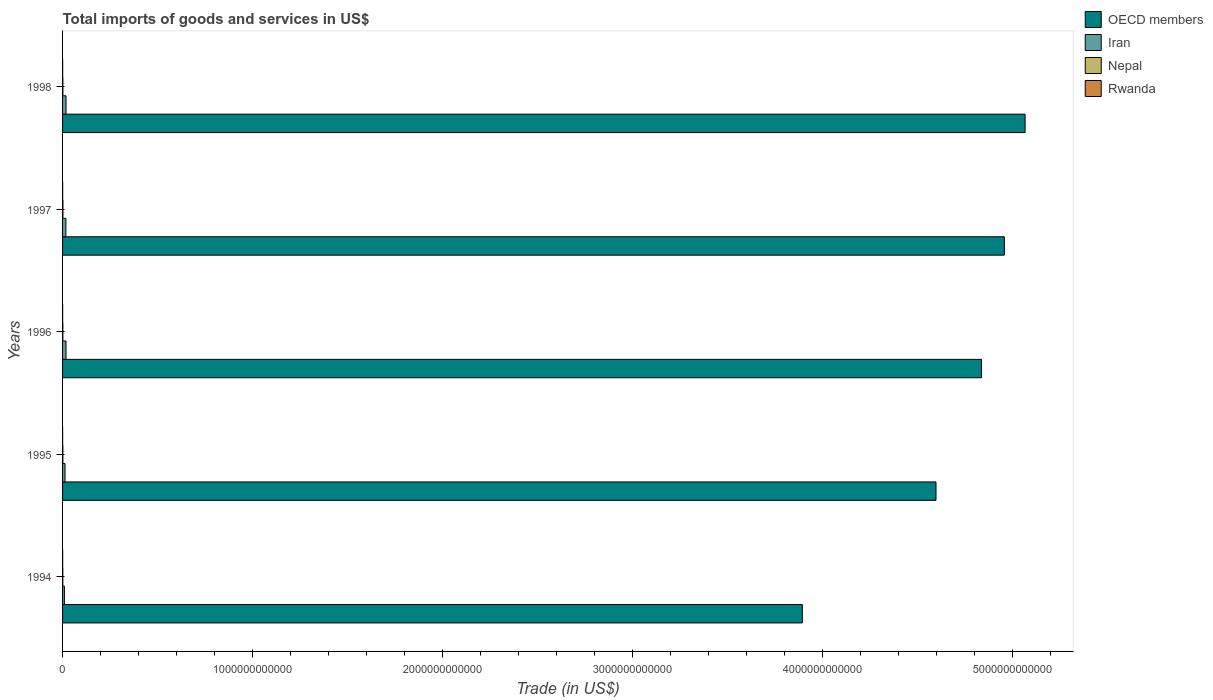How many bars are there on the 4th tick from the top?
Your answer should be very brief. 4. What is the label of the 3rd group of bars from the top?
Offer a terse response. 1996. In how many cases, is the number of bars for a given year not equal to the number of legend labels?
Give a very brief answer. 0. What is the total imports of goods and services in Rwanda in 1994?
Offer a terse response. 4.88e+08. Across all years, what is the maximum total imports of goods and services in Rwanda?
Offer a terse response. 4.88e+08. Across all years, what is the minimum total imports of goods and services in OECD members?
Provide a short and direct response. 3.89e+12. In which year was the total imports of goods and services in Rwanda maximum?
Ensure brevity in your answer.  1994. What is the total total imports of goods and services in Rwanda in the graph?
Ensure brevity in your answer.  2.12e+09. What is the difference between the total imports of goods and services in Nepal in 1994 and that in 1997?
Provide a succinct answer. -5.76e+08. What is the difference between the total imports of goods and services in Iran in 1995 and the total imports of goods and services in OECD members in 1998?
Provide a short and direct response. -5.05e+12. What is the average total imports of goods and services in Iran per year?
Provide a short and direct response. 1.53e+1. In the year 1996, what is the difference between the total imports of goods and services in OECD members and total imports of goods and services in Nepal?
Make the answer very short. 4.84e+12. In how many years, is the total imports of goods and services in Rwanda greater than 3800000000000 US$?
Your response must be concise. 0. What is the ratio of the total imports of goods and services in Iran in 1994 to that in 1996?
Provide a succinct answer. 0.53. Is the difference between the total imports of goods and services in OECD members in 1997 and 1998 greater than the difference between the total imports of goods and services in Nepal in 1997 and 1998?
Provide a succinct answer. No. What is the difference between the highest and the second highest total imports of goods and services in Rwanda?
Your answer should be very brief. 1.30e+07. What is the difference between the highest and the lowest total imports of goods and services in Nepal?
Ensure brevity in your answer.  5.76e+08. In how many years, is the total imports of goods and services in OECD members greater than the average total imports of goods and services in OECD members taken over all years?
Your answer should be compact. 3. What does the 2nd bar from the top in 1997 represents?
Offer a very short reply. Nepal. How many bars are there?
Your response must be concise. 20. What is the difference between two consecutive major ticks on the X-axis?
Provide a succinct answer. 1.00e+12. Where does the legend appear in the graph?
Offer a terse response. Top right. What is the title of the graph?
Make the answer very short. Total imports of goods and services in US$. What is the label or title of the X-axis?
Ensure brevity in your answer.  Trade (in US$). What is the label or title of the Y-axis?
Keep it short and to the point. Years. What is the Trade (in US$) of OECD members in 1994?
Give a very brief answer. 3.89e+12. What is the Trade (in US$) of Iran in 1994?
Your answer should be compact. 9.57e+09. What is the Trade (in US$) in Nepal in 1994?
Make the answer very short. 1.28e+09. What is the Trade (in US$) in Rwanda in 1994?
Offer a terse response. 4.88e+08. What is the Trade (in US$) in OECD members in 1995?
Offer a very short reply. 4.60e+12. What is the Trade (in US$) of Iran in 1995?
Offer a terse response. 1.30e+1. What is the Trade (in US$) of Nepal in 1995?
Ensure brevity in your answer.  1.52e+09. What is the Trade (in US$) in Rwanda in 1995?
Your answer should be very brief. 3.34e+08. What is the Trade (in US$) in OECD members in 1996?
Your answer should be very brief. 4.84e+12. What is the Trade (in US$) in Iran in 1996?
Ensure brevity in your answer.  1.81e+1. What is the Trade (in US$) in Nepal in 1996?
Offer a terse response. 1.61e+09. What is the Trade (in US$) of Rwanda in 1996?
Provide a short and direct response. 3.62e+08. What is the Trade (in US$) of OECD members in 1997?
Provide a short and direct response. 4.96e+12. What is the Trade (in US$) in Iran in 1997?
Your answer should be compact. 1.75e+1. What is the Trade (in US$) in Nepal in 1997?
Offer a terse response. 1.85e+09. What is the Trade (in US$) of Rwanda in 1997?
Ensure brevity in your answer.  4.75e+08. What is the Trade (in US$) in OECD members in 1998?
Provide a succinct answer. 5.07e+12. What is the Trade (in US$) in Iran in 1998?
Provide a succinct answer. 1.82e+1. What is the Trade (in US$) of Nepal in 1998?
Your response must be concise. 1.65e+09. What is the Trade (in US$) of Rwanda in 1998?
Ensure brevity in your answer.  4.62e+08. Across all years, what is the maximum Trade (in US$) of OECD members?
Provide a short and direct response. 5.07e+12. Across all years, what is the maximum Trade (in US$) of Iran?
Provide a succinct answer. 1.82e+1. Across all years, what is the maximum Trade (in US$) in Nepal?
Your answer should be very brief. 1.85e+09. Across all years, what is the maximum Trade (in US$) of Rwanda?
Ensure brevity in your answer.  4.88e+08. Across all years, what is the minimum Trade (in US$) of OECD members?
Keep it short and to the point. 3.89e+12. Across all years, what is the minimum Trade (in US$) of Iran?
Provide a short and direct response. 9.57e+09. Across all years, what is the minimum Trade (in US$) in Nepal?
Keep it short and to the point. 1.28e+09. Across all years, what is the minimum Trade (in US$) of Rwanda?
Ensure brevity in your answer.  3.34e+08. What is the total Trade (in US$) in OECD members in the graph?
Make the answer very short. 2.34e+13. What is the total Trade (in US$) in Iran in the graph?
Provide a short and direct response. 7.64e+1. What is the total Trade (in US$) in Nepal in the graph?
Offer a terse response. 7.91e+09. What is the total Trade (in US$) in Rwanda in the graph?
Provide a short and direct response. 2.12e+09. What is the difference between the Trade (in US$) in OECD members in 1994 and that in 1995?
Provide a short and direct response. -7.04e+11. What is the difference between the Trade (in US$) in Iran in 1994 and that in 1995?
Provide a short and direct response. -3.41e+09. What is the difference between the Trade (in US$) in Nepal in 1994 and that in 1995?
Keep it short and to the point. -2.41e+08. What is the difference between the Trade (in US$) of Rwanda in 1994 and that in 1995?
Make the answer very short. 1.54e+08. What is the difference between the Trade (in US$) in OECD members in 1994 and that in 1996?
Provide a short and direct response. -9.43e+11. What is the difference between the Trade (in US$) of Iran in 1994 and that in 1996?
Your answer should be very brief. -8.52e+09. What is the difference between the Trade (in US$) in Nepal in 1994 and that in 1996?
Give a very brief answer. -3.33e+08. What is the difference between the Trade (in US$) of Rwanda in 1994 and that in 1996?
Keep it short and to the point. 1.26e+08. What is the difference between the Trade (in US$) in OECD members in 1994 and that in 1997?
Make the answer very short. -1.06e+12. What is the difference between the Trade (in US$) of Iran in 1994 and that in 1997?
Provide a succinct answer. -7.94e+09. What is the difference between the Trade (in US$) in Nepal in 1994 and that in 1997?
Your answer should be very brief. -5.76e+08. What is the difference between the Trade (in US$) of Rwanda in 1994 and that in 1997?
Your answer should be compact. 1.30e+07. What is the difference between the Trade (in US$) of OECD members in 1994 and that in 1998?
Ensure brevity in your answer.  -1.17e+12. What is the difference between the Trade (in US$) of Iran in 1994 and that in 1998?
Make the answer very short. -8.67e+09. What is the difference between the Trade (in US$) of Nepal in 1994 and that in 1998?
Keep it short and to the point. -3.67e+08. What is the difference between the Trade (in US$) of Rwanda in 1994 and that in 1998?
Offer a very short reply. 2.66e+07. What is the difference between the Trade (in US$) of OECD members in 1995 and that in 1996?
Make the answer very short. -2.40e+11. What is the difference between the Trade (in US$) in Iran in 1995 and that in 1996?
Make the answer very short. -5.11e+09. What is the difference between the Trade (in US$) in Nepal in 1995 and that in 1996?
Ensure brevity in your answer.  -9.24e+07. What is the difference between the Trade (in US$) in Rwanda in 1995 and that in 1996?
Provide a short and direct response. -2.81e+07. What is the difference between the Trade (in US$) in OECD members in 1995 and that in 1997?
Your answer should be compact. -3.60e+11. What is the difference between the Trade (in US$) of Iran in 1995 and that in 1997?
Make the answer very short. -4.53e+09. What is the difference between the Trade (in US$) of Nepal in 1995 and that in 1997?
Keep it short and to the point. -3.36e+08. What is the difference between the Trade (in US$) in Rwanda in 1995 and that in 1997?
Keep it short and to the point. -1.41e+08. What is the difference between the Trade (in US$) in OECD members in 1995 and that in 1998?
Offer a terse response. -4.69e+11. What is the difference between the Trade (in US$) of Iran in 1995 and that in 1998?
Keep it short and to the point. -5.26e+09. What is the difference between the Trade (in US$) in Nepal in 1995 and that in 1998?
Your answer should be compact. -1.27e+08. What is the difference between the Trade (in US$) in Rwanda in 1995 and that in 1998?
Your answer should be very brief. -1.28e+08. What is the difference between the Trade (in US$) of OECD members in 1996 and that in 1997?
Offer a terse response. -1.20e+11. What is the difference between the Trade (in US$) of Iran in 1996 and that in 1997?
Give a very brief answer. 5.81e+08. What is the difference between the Trade (in US$) in Nepal in 1996 and that in 1997?
Keep it short and to the point. -2.43e+08. What is the difference between the Trade (in US$) in Rwanda in 1996 and that in 1997?
Keep it short and to the point. -1.13e+08. What is the difference between the Trade (in US$) in OECD members in 1996 and that in 1998?
Offer a very short reply. -2.29e+11. What is the difference between the Trade (in US$) in Iran in 1996 and that in 1998?
Your answer should be compact. -1.53e+08. What is the difference between the Trade (in US$) in Nepal in 1996 and that in 1998?
Your response must be concise. -3.42e+07. What is the difference between the Trade (in US$) in Rwanda in 1996 and that in 1998?
Give a very brief answer. -9.96e+07. What is the difference between the Trade (in US$) of OECD members in 1997 and that in 1998?
Give a very brief answer. -1.09e+11. What is the difference between the Trade (in US$) in Iran in 1997 and that in 1998?
Offer a terse response. -7.34e+08. What is the difference between the Trade (in US$) in Nepal in 1997 and that in 1998?
Your answer should be very brief. 2.09e+08. What is the difference between the Trade (in US$) in Rwanda in 1997 and that in 1998?
Ensure brevity in your answer.  1.36e+07. What is the difference between the Trade (in US$) in OECD members in 1994 and the Trade (in US$) in Iran in 1995?
Make the answer very short. 3.88e+12. What is the difference between the Trade (in US$) in OECD members in 1994 and the Trade (in US$) in Nepal in 1995?
Your answer should be very brief. 3.89e+12. What is the difference between the Trade (in US$) of OECD members in 1994 and the Trade (in US$) of Rwanda in 1995?
Make the answer very short. 3.89e+12. What is the difference between the Trade (in US$) in Iran in 1994 and the Trade (in US$) in Nepal in 1995?
Make the answer very short. 8.05e+09. What is the difference between the Trade (in US$) of Iran in 1994 and the Trade (in US$) of Rwanda in 1995?
Provide a succinct answer. 9.24e+09. What is the difference between the Trade (in US$) of Nepal in 1994 and the Trade (in US$) of Rwanda in 1995?
Provide a succinct answer. 9.45e+08. What is the difference between the Trade (in US$) of OECD members in 1994 and the Trade (in US$) of Iran in 1996?
Provide a short and direct response. 3.88e+12. What is the difference between the Trade (in US$) in OECD members in 1994 and the Trade (in US$) in Nepal in 1996?
Ensure brevity in your answer.  3.89e+12. What is the difference between the Trade (in US$) of OECD members in 1994 and the Trade (in US$) of Rwanda in 1996?
Keep it short and to the point. 3.89e+12. What is the difference between the Trade (in US$) of Iran in 1994 and the Trade (in US$) of Nepal in 1996?
Give a very brief answer. 7.96e+09. What is the difference between the Trade (in US$) of Iran in 1994 and the Trade (in US$) of Rwanda in 1996?
Make the answer very short. 9.21e+09. What is the difference between the Trade (in US$) of Nepal in 1994 and the Trade (in US$) of Rwanda in 1996?
Make the answer very short. 9.16e+08. What is the difference between the Trade (in US$) in OECD members in 1994 and the Trade (in US$) in Iran in 1997?
Ensure brevity in your answer.  3.88e+12. What is the difference between the Trade (in US$) of OECD members in 1994 and the Trade (in US$) of Nepal in 1997?
Make the answer very short. 3.89e+12. What is the difference between the Trade (in US$) of OECD members in 1994 and the Trade (in US$) of Rwanda in 1997?
Your answer should be compact. 3.89e+12. What is the difference between the Trade (in US$) of Iran in 1994 and the Trade (in US$) of Nepal in 1997?
Ensure brevity in your answer.  7.72e+09. What is the difference between the Trade (in US$) of Iran in 1994 and the Trade (in US$) of Rwanda in 1997?
Your response must be concise. 9.10e+09. What is the difference between the Trade (in US$) of Nepal in 1994 and the Trade (in US$) of Rwanda in 1997?
Offer a terse response. 8.03e+08. What is the difference between the Trade (in US$) in OECD members in 1994 and the Trade (in US$) in Iran in 1998?
Your answer should be very brief. 3.88e+12. What is the difference between the Trade (in US$) of OECD members in 1994 and the Trade (in US$) of Nepal in 1998?
Provide a short and direct response. 3.89e+12. What is the difference between the Trade (in US$) of OECD members in 1994 and the Trade (in US$) of Rwanda in 1998?
Offer a terse response. 3.89e+12. What is the difference between the Trade (in US$) in Iran in 1994 and the Trade (in US$) in Nepal in 1998?
Your answer should be very brief. 7.93e+09. What is the difference between the Trade (in US$) in Iran in 1994 and the Trade (in US$) in Rwanda in 1998?
Give a very brief answer. 9.11e+09. What is the difference between the Trade (in US$) of Nepal in 1994 and the Trade (in US$) of Rwanda in 1998?
Your answer should be very brief. 8.17e+08. What is the difference between the Trade (in US$) of OECD members in 1995 and the Trade (in US$) of Iran in 1996?
Provide a succinct answer. 4.58e+12. What is the difference between the Trade (in US$) in OECD members in 1995 and the Trade (in US$) in Nepal in 1996?
Give a very brief answer. 4.60e+12. What is the difference between the Trade (in US$) of OECD members in 1995 and the Trade (in US$) of Rwanda in 1996?
Your answer should be compact. 4.60e+12. What is the difference between the Trade (in US$) in Iran in 1995 and the Trade (in US$) in Nepal in 1996?
Keep it short and to the point. 1.14e+1. What is the difference between the Trade (in US$) in Iran in 1995 and the Trade (in US$) in Rwanda in 1996?
Offer a very short reply. 1.26e+1. What is the difference between the Trade (in US$) of Nepal in 1995 and the Trade (in US$) of Rwanda in 1996?
Make the answer very short. 1.16e+09. What is the difference between the Trade (in US$) in OECD members in 1995 and the Trade (in US$) in Iran in 1997?
Your response must be concise. 4.58e+12. What is the difference between the Trade (in US$) of OECD members in 1995 and the Trade (in US$) of Nepal in 1997?
Keep it short and to the point. 4.60e+12. What is the difference between the Trade (in US$) in OECD members in 1995 and the Trade (in US$) in Rwanda in 1997?
Keep it short and to the point. 4.60e+12. What is the difference between the Trade (in US$) in Iran in 1995 and the Trade (in US$) in Nepal in 1997?
Your answer should be compact. 1.11e+1. What is the difference between the Trade (in US$) of Iran in 1995 and the Trade (in US$) of Rwanda in 1997?
Provide a succinct answer. 1.25e+1. What is the difference between the Trade (in US$) of Nepal in 1995 and the Trade (in US$) of Rwanda in 1997?
Offer a very short reply. 1.04e+09. What is the difference between the Trade (in US$) in OECD members in 1995 and the Trade (in US$) in Iran in 1998?
Provide a short and direct response. 4.58e+12. What is the difference between the Trade (in US$) of OECD members in 1995 and the Trade (in US$) of Nepal in 1998?
Provide a succinct answer. 4.60e+12. What is the difference between the Trade (in US$) of OECD members in 1995 and the Trade (in US$) of Rwanda in 1998?
Offer a terse response. 4.60e+12. What is the difference between the Trade (in US$) of Iran in 1995 and the Trade (in US$) of Nepal in 1998?
Keep it short and to the point. 1.13e+1. What is the difference between the Trade (in US$) in Iran in 1995 and the Trade (in US$) in Rwanda in 1998?
Offer a terse response. 1.25e+1. What is the difference between the Trade (in US$) in Nepal in 1995 and the Trade (in US$) in Rwanda in 1998?
Make the answer very short. 1.06e+09. What is the difference between the Trade (in US$) in OECD members in 1996 and the Trade (in US$) in Iran in 1997?
Offer a very short reply. 4.82e+12. What is the difference between the Trade (in US$) of OECD members in 1996 and the Trade (in US$) of Nepal in 1997?
Provide a short and direct response. 4.84e+12. What is the difference between the Trade (in US$) in OECD members in 1996 and the Trade (in US$) in Rwanda in 1997?
Your answer should be very brief. 4.84e+12. What is the difference between the Trade (in US$) of Iran in 1996 and the Trade (in US$) of Nepal in 1997?
Provide a succinct answer. 1.62e+1. What is the difference between the Trade (in US$) of Iran in 1996 and the Trade (in US$) of Rwanda in 1997?
Offer a terse response. 1.76e+1. What is the difference between the Trade (in US$) of Nepal in 1996 and the Trade (in US$) of Rwanda in 1997?
Offer a terse response. 1.14e+09. What is the difference between the Trade (in US$) of OECD members in 1996 and the Trade (in US$) of Iran in 1998?
Make the answer very short. 4.82e+12. What is the difference between the Trade (in US$) of OECD members in 1996 and the Trade (in US$) of Nepal in 1998?
Give a very brief answer. 4.84e+12. What is the difference between the Trade (in US$) of OECD members in 1996 and the Trade (in US$) of Rwanda in 1998?
Offer a very short reply. 4.84e+12. What is the difference between the Trade (in US$) of Iran in 1996 and the Trade (in US$) of Nepal in 1998?
Provide a short and direct response. 1.64e+1. What is the difference between the Trade (in US$) in Iran in 1996 and the Trade (in US$) in Rwanda in 1998?
Provide a succinct answer. 1.76e+1. What is the difference between the Trade (in US$) in Nepal in 1996 and the Trade (in US$) in Rwanda in 1998?
Give a very brief answer. 1.15e+09. What is the difference between the Trade (in US$) in OECD members in 1997 and the Trade (in US$) in Iran in 1998?
Your answer should be very brief. 4.94e+12. What is the difference between the Trade (in US$) in OECD members in 1997 and the Trade (in US$) in Nepal in 1998?
Offer a very short reply. 4.96e+12. What is the difference between the Trade (in US$) of OECD members in 1997 and the Trade (in US$) of Rwanda in 1998?
Your answer should be very brief. 4.96e+12. What is the difference between the Trade (in US$) in Iran in 1997 and the Trade (in US$) in Nepal in 1998?
Make the answer very short. 1.59e+1. What is the difference between the Trade (in US$) in Iran in 1997 and the Trade (in US$) in Rwanda in 1998?
Give a very brief answer. 1.70e+1. What is the difference between the Trade (in US$) of Nepal in 1997 and the Trade (in US$) of Rwanda in 1998?
Your response must be concise. 1.39e+09. What is the average Trade (in US$) of OECD members per year?
Provide a short and direct response. 4.67e+12. What is the average Trade (in US$) in Iran per year?
Offer a very short reply. 1.53e+1. What is the average Trade (in US$) of Nepal per year?
Provide a short and direct response. 1.58e+09. What is the average Trade (in US$) in Rwanda per year?
Provide a succinct answer. 4.24e+08. In the year 1994, what is the difference between the Trade (in US$) of OECD members and Trade (in US$) of Iran?
Your answer should be compact. 3.88e+12. In the year 1994, what is the difference between the Trade (in US$) in OECD members and Trade (in US$) in Nepal?
Offer a very short reply. 3.89e+12. In the year 1994, what is the difference between the Trade (in US$) in OECD members and Trade (in US$) in Rwanda?
Your response must be concise. 3.89e+12. In the year 1994, what is the difference between the Trade (in US$) in Iran and Trade (in US$) in Nepal?
Your answer should be compact. 8.29e+09. In the year 1994, what is the difference between the Trade (in US$) in Iran and Trade (in US$) in Rwanda?
Your response must be concise. 9.08e+09. In the year 1994, what is the difference between the Trade (in US$) of Nepal and Trade (in US$) of Rwanda?
Keep it short and to the point. 7.90e+08. In the year 1995, what is the difference between the Trade (in US$) of OECD members and Trade (in US$) of Iran?
Ensure brevity in your answer.  4.59e+12. In the year 1995, what is the difference between the Trade (in US$) of OECD members and Trade (in US$) of Nepal?
Your answer should be very brief. 4.60e+12. In the year 1995, what is the difference between the Trade (in US$) in OECD members and Trade (in US$) in Rwanda?
Offer a very short reply. 4.60e+12. In the year 1995, what is the difference between the Trade (in US$) in Iran and Trade (in US$) in Nepal?
Your response must be concise. 1.15e+1. In the year 1995, what is the difference between the Trade (in US$) in Iran and Trade (in US$) in Rwanda?
Your answer should be compact. 1.27e+1. In the year 1995, what is the difference between the Trade (in US$) of Nepal and Trade (in US$) of Rwanda?
Offer a very short reply. 1.19e+09. In the year 1996, what is the difference between the Trade (in US$) in OECD members and Trade (in US$) in Iran?
Ensure brevity in your answer.  4.82e+12. In the year 1996, what is the difference between the Trade (in US$) of OECD members and Trade (in US$) of Nepal?
Your answer should be very brief. 4.84e+12. In the year 1996, what is the difference between the Trade (in US$) in OECD members and Trade (in US$) in Rwanda?
Your answer should be compact. 4.84e+12. In the year 1996, what is the difference between the Trade (in US$) in Iran and Trade (in US$) in Nepal?
Offer a terse response. 1.65e+1. In the year 1996, what is the difference between the Trade (in US$) in Iran and Trade (in US$) in Rwanda?
Ensure brevity in your answer.  1.77e+1. In the year 1996, what is the difference between the Trade (in US$) in Nepal and Trade (in US$) in Rwanda?
Ensure brevity in your answer.  1.25e+09. In the year 1997, what is the difference between the Trade (in US$) in OECD members and Trade (in US$) in Iran?
Offer a very short reply. 4.94e+12. In the year 1997, what is the difference between the Trade (in US$) in OECD members and Trade (in US$) in Nepal?
Make the answer very short. 4.96e+12. In the year 1997, what is the difference between the Trade (in US$) of OECD members and Trade (in US$) of Rwanda?
Give a very brief answer. 4.96e+12. In the year 1997, what is the difference between the Trade (in US$) in Iran and Trade (in US$) in Nepal?
Offer a very short reply. 1.57e+1. In the year 1997, what is the difference between the Trade (in US$) in Iran and Trade (in US$) in Rwanda?
Give a very brief answer. 1.70e+1. In the year 1997, what is the difference between the Trade (in US$) in Nepal and Trade (in US$) in Rwanda?
Your answer should be compact. 1.38e+09. In the year 1998, what is the difference between the Trade (in US$) of OECD members and Trade (in US$) of Iran?
Your answer should be compact. 5.05e+12. In the year 1998, what is the difference between the Trade (in US$) of OECD members and Trade (in US$) of Nepal?
Make the answer very short. 5.07e+12. In the year 1998, what is the difference between the Trade (in US$) of OECD members and Trade (in US$) of Rwanda?
Keep it short and to the point. 5.07e+12. In the year 1998, what is the difference between the Trade (in US$) in Iran and Trade (in US$) in Nepal?
Your answer should be very brief. 1.66e+1. In the year 1998, what is the difference between the Trade (in US$) of Iran and Trade (in US$) of Rwanda?
Your answer should be compact. 1.78e+1. In the year 1998, what is the difference between the Trade (in US$) of Nepal and Trade (in US$) of Rwanda?
Provide a succinct answer. 1.18e+09. What is the ratio of the Trade (in US$) of OECD members in 1994 to that in 1995?
Keep it short and to the point. 0.85. What is the ratio of the Trade (in US$) of Iran in 1994 to that in 1995?
Your answer should be compact. 0.74. What is the ratio of the Trade (in US$) in Nepal in 1994 to that in 1995?
Your answer should be compact. 0.84. What is the ratio of the Trade (in US$) in Rwanda in 1994 to that in 1995?
Keep it short and to the point. 1.46. What is the ratio of the Trade (in US$) in OECD members in 1994 to that in 1996?
Offer a very short reply. 0.81. What is the ratio of the Trade (in US$) of Iran in 1994 to that in 1996?
Give a very brief answer. 0.53. What is the ratio of the Trade (in US$) in Nepal in 1994 to that in 1996?
Provide a succinct answer. 0.79. What is the ratio of the Trade (in US$) of Rwanda in 1994 to that in 1996?
Give a very brief answer. 1.35. What is the ratio of the Trade (in US$) in OECD members in 1994 to that in 1997?
Your answer should be very brief. 0.79. What is the ratio of the Trade (in US$) of Iran in 1994 to that in 1997?
Ensure brevity in your answer.  0.55. What is the ratio of the Trade (in US$) of Nepal in 1994 to that in 1997?
Give a very brief answer. 0.69. What is the ratio of the Trade (in US$) in Rwanda in 1994 to that in 1997?
Provide a short and direct response. 1.03. What is the ratio of the Trade (in US$) of OECD members in 1994 to that in 1998?
Make the answer very short. 0.77. What is the ratio of the Trade (in US$) of Iran in 1994 to that in 1998?
Keep it short and to the point. 0.52. What is the ratio of the Trade (in US$) in Nepal in 1994 to that in 1998?
Ensure brevity in your answer.  0.78. What is the ratio of the Trade (in US$) in Rwanda in 1994 to that in 1998?
Your response must be concise. 1.06. What is the ratio of the Trade (in US$) in OECD members in 1995 to that in 1996?
Make the answer very short. 0.95. What is the ratio of the Trade (in US$) in Iran in 1995 to that in 1996?
Your response must be concise. 0.72. What is the ratio of the Trade (in US$) of Nepal in 1995 to that in 1996?
Keep it short and to the point. 0.94. What is the ratio of the Trade (in US$) of Rwanda in 1995 to that in 1996?
Provide a short and direct response. 0.92. What is the ratio of the Trade (in US$) of OECD members in 1995 to that in 1997?
Provide a succinct answer. 0.93. What is the ratio of the Trade (in US$) of Iran in 1995 to that in 1997?
Offer a very short reply. 0.74. What is the ratio of the Trade (in US$) of Nepal in 1995 to that in 1997?
Offer a very short reply. 0.82. What is the ratio of the Trade (in US$) of Rwanda in 1995 to that in 1997?
Make the answer very short. 0.7. What is the ratio of the Trade (in US$) of OECD members in 1995 to that in 1998?
Provide a short and direct response. 0.91. What is the ratio of the Trade (in US$) in Iran in 1995 to that in 1998?
Your answer should be very brief. 0.71. What is the ratio of the Trade (in US$) of Nepal in 1995 to that in 1998?
Provide a short and direct response. 0.92. What is the ratio of the Trade (in US$) in Rwanda in 1995 to that in 1998?
Provide a short and direct response. 0.72. What is the ratio of the Trade (in US$) of OECD members in 1996 to that in 1997?
Provide a succinct answer. 0.98. What is the ratio of the Trade (in US$) in Iran in 1996 to that in 1997?
Make the answer very short. 1.03. What is the ratio of the Trade (in US$) of Nepal in 1996 to that in 1997?
Offer a terse response. 0.87. What is the ratio of the Trade (in US$) of Rwanda in 1996 to that in 1997?
Offer a terse response. 0.76. What is the ratio of the Trade (in US$) of OECD members in 1996 to that in 1998?
Provide a short and direct response. 0.95. What is the ratio of the Trade (in US$) in Iran in 1996 to that in 1998?
Give a very brief answer. 0.99. What is the ratio of the Trade (in US$) of Nepal in 1996 to that in 1998?
Offer a very short reply. 0.98. What is the ratio of the Trade (in US$) of Rwanda in 1996 to that in 1998?
Provide a short and direct response. 0.78. What is the ratio of the Trade (in US$) in OECD members in 1997 to that in 1998?
Give a very brief answer. 0.98. What is the ratio of the Trade (in US$) of Iran in 1997 to that in 1998?
Provide a succinct answer. 0.96. What is the ratio of the Trade (in US$) in Nepal in 1997 to that in 1998?
Provide a short and direct response. 1.13. What is the ratio of the Trade (in US$) in Rwanda in 1997 to that in 1998?
Provide a succinct answer. 1.03. What is the difference between the highest and the second highest Trade (in US$) in OECD members?
Offer a terse response. 1.09e+11. What is the difference between the highest and the second highest Trade (in US$) of Iran?
Ensure brevity in your answer.  1.53e+08. What is the difference between the highest and the second highest Trade (in US$) of Nepal?
Your answer should be very brief. 2.09e+08. What is the difference between the highest and the second highest Trade (in US$) of Rwanda?
Provide a short and direct response. 1.30e+07. What is the difference between the highest and the lowest Trade (in US$) in OECD members?
Your answer should be compact. 1.17e+12. What is the difference between the highest and the lowest Trade (in US$) of Iran?
Ensure brevity in your answer.  8.67e+09. What is the difference between the highest and the lowest Trade (in US$) of Nepal?
Keep it short and to the point. 5.76e+08. What is the difference between the highest and the lowest Trade (in US$) in Rwanda?
Keep it short and to the point. 1.54e+08. 